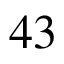Convert formula to latex. <formula><loc_0><loc_0><loc_500><loc_500>4 3</formula> 